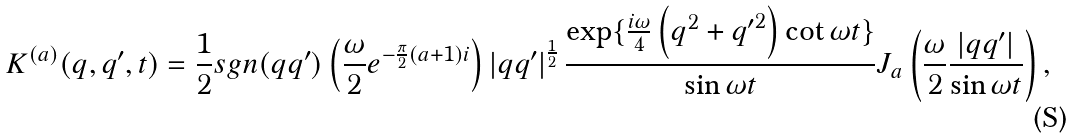Convert formula to latex. <formula><loc_0><loc_0><loc_500><loc_500>K ^ { ( a ) } ( q , q ^ { \prime } , t ) = \frac { 1 } { 2 } s g n ( q q ^ { \prime } ) \left ( \frac { \omega } { 2 } e ^ { - \frac { \pi } { 2 } ( a + 1 ) i } \right ) \left | q q ^ { \prime } \right | ^ { \frac { 1 } { 2 } } \frac { \exp \{ \frac { i \omega } { 4 } \left ( q ^ { 2 } + { q ^ { \prime } } ^ { 2 } \right ) \cot \omega t \} } { \sin \omega t } J _ { a } \left ( \frac { \omega } { 2 } \frac { | q q ^ { \prime } | } { \sin \omega t } \right ) ,</formula> 